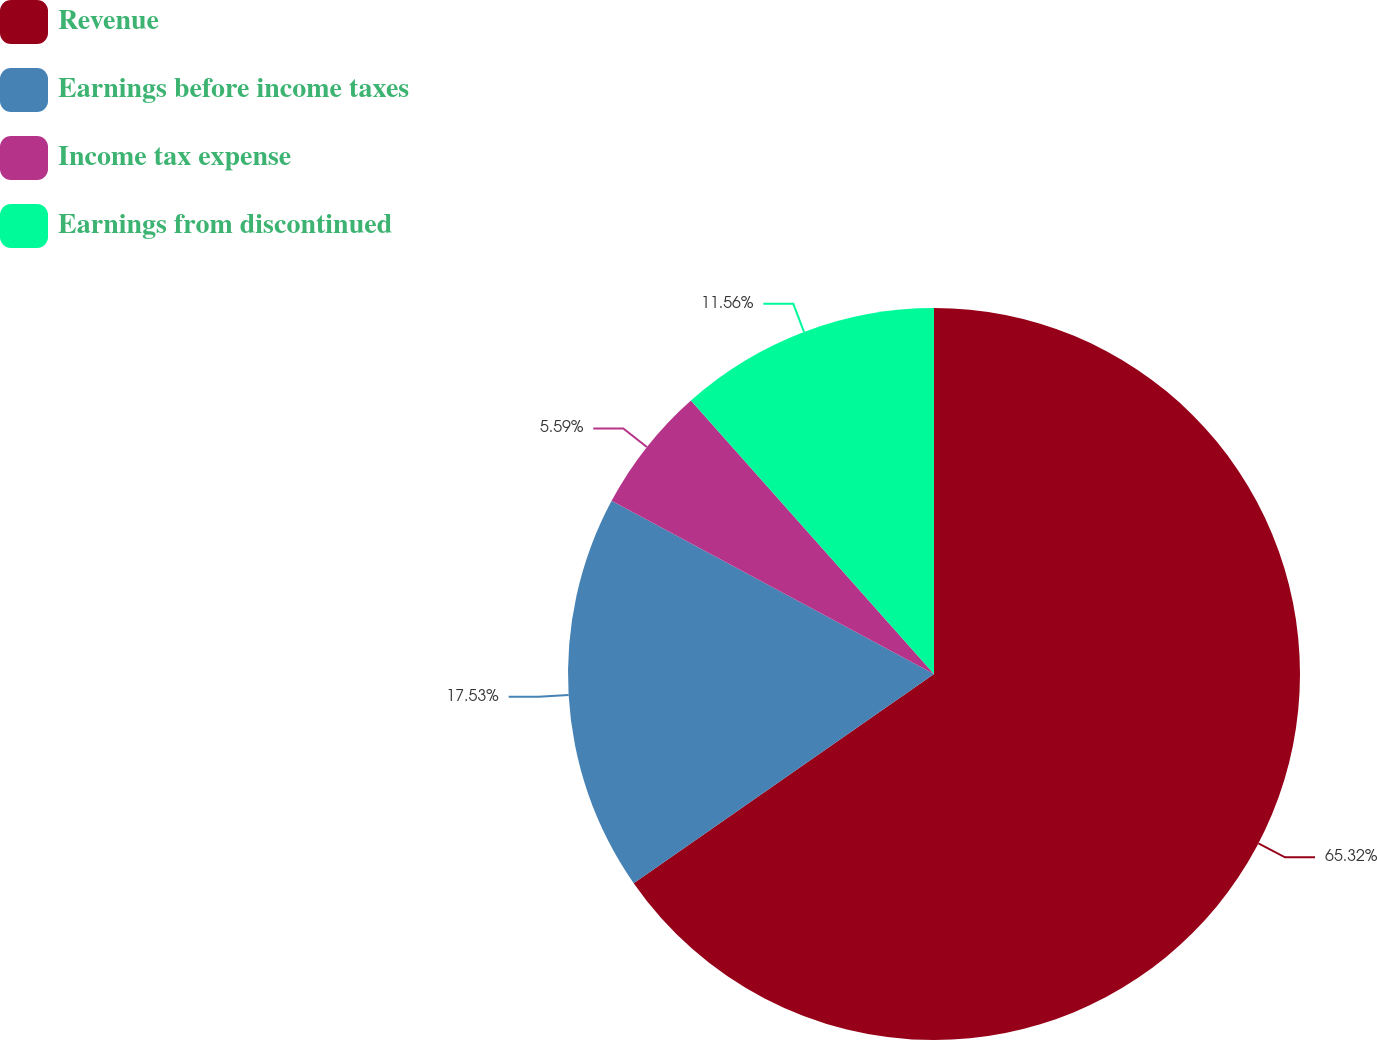<chart> <loc_0><loc_0><loc_500><loc_500><pie_chart><fcel>Revenue<fcel>Earnings before income taxes<fcel>Income tax expense<fcel>Earnings from discontinued<nl><fcel>65.31%<fcel>17.53%<fcel>5.59%<fcel>11.56%<nl></chart> 